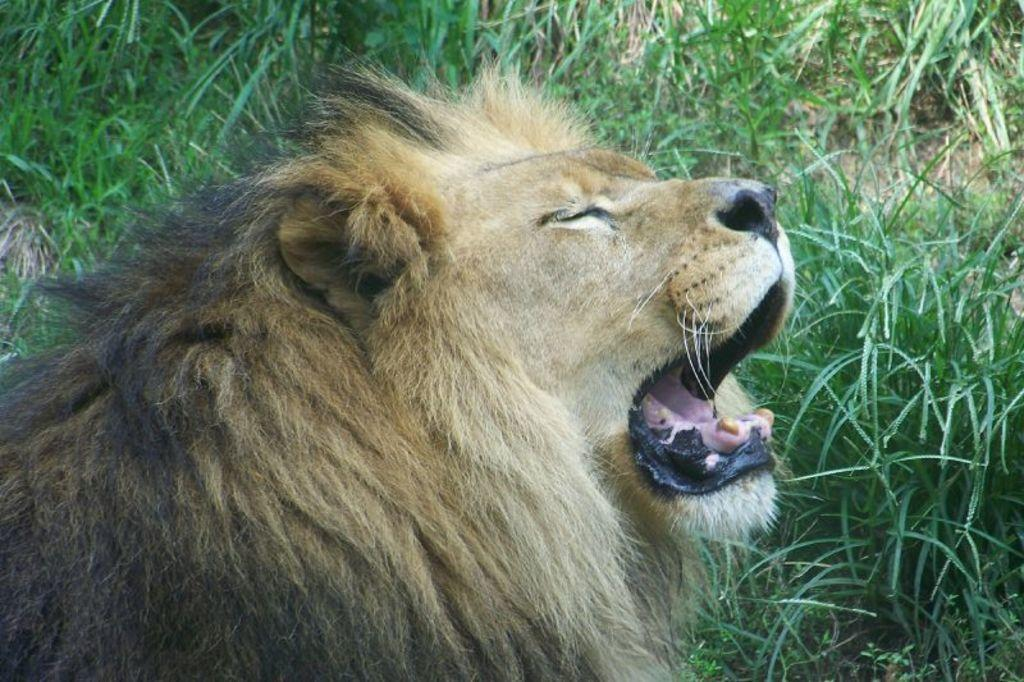What animal is the main subject of the image? There is a lion in the image. What is the lion doing in the image? The lion has its mouth open. What type of vegetation is visible at the bottom of the image? There is grass at the bottom of the image. What type of pipe can be seen in the lion's mouth in the image? There is no pipe present in the lion's mouth or in the image. What kind of loaf is the lion holding in its paws in the image? There is no loaf present in the image; the lion has its mouth open and is not holding anything. 